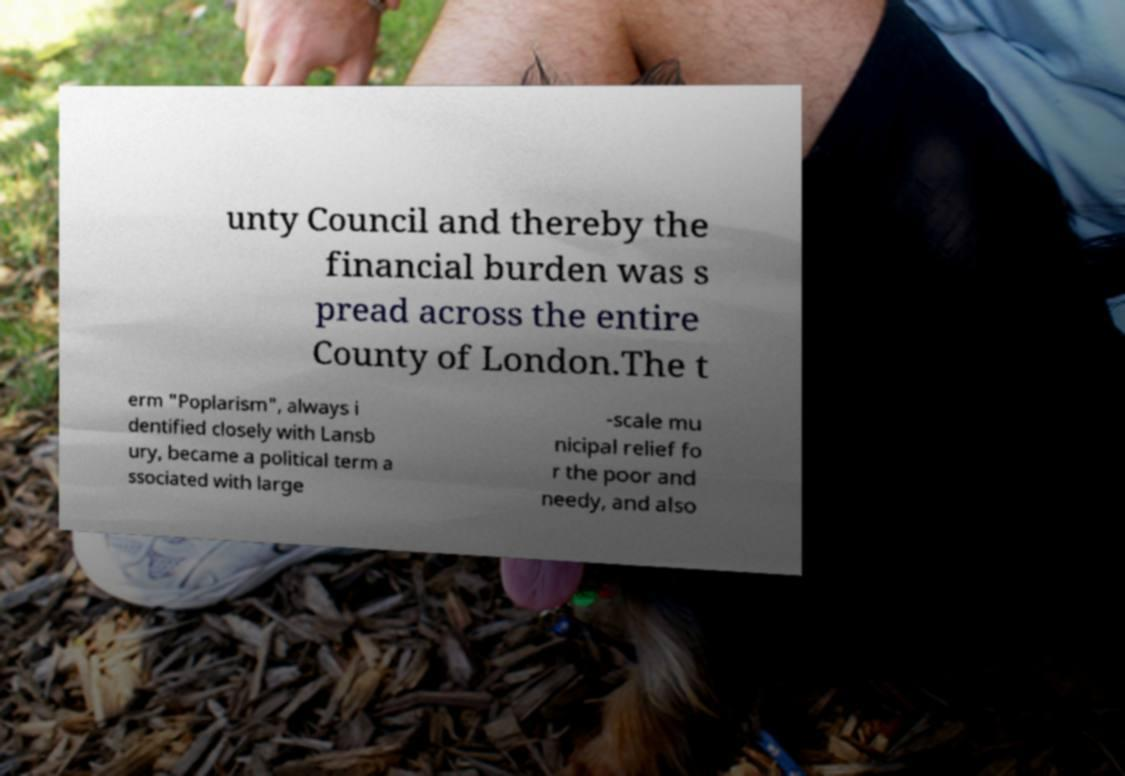There's text embedded in this image that I need extracted. Can you transcribe it verbatim? unty Council and thereby the financial burden was s pread across the entire County of London.The t erm "Poplarism", always i dentified closely with Lansb ury, became a political term a ssociated with large -scale mu nicipal relief fo r the poor and needy, and also 